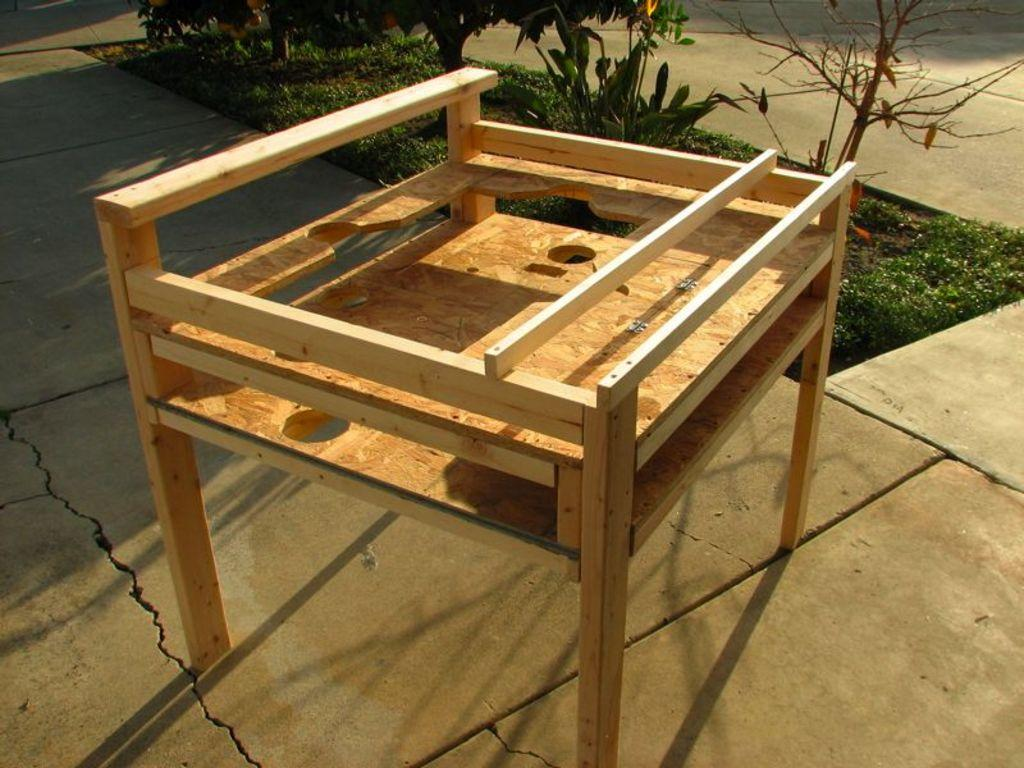What is the main object in the center of the image? There is a wooden object, possibly a bench, in the center of the image. What type of vegetation is present in the image? There are plants and grass at the top of the image. What type of surface is visible in the image? There is pavement visible in the image. How would you describe the weather in the image? The sky is sunny in the image. Where are the scissors placed in the image? There are no scissors present in the image. What type of monkey can be seen climbing the wooden object in the image? There is no monkey present in the image; it features a wooden object that could be a bench. 